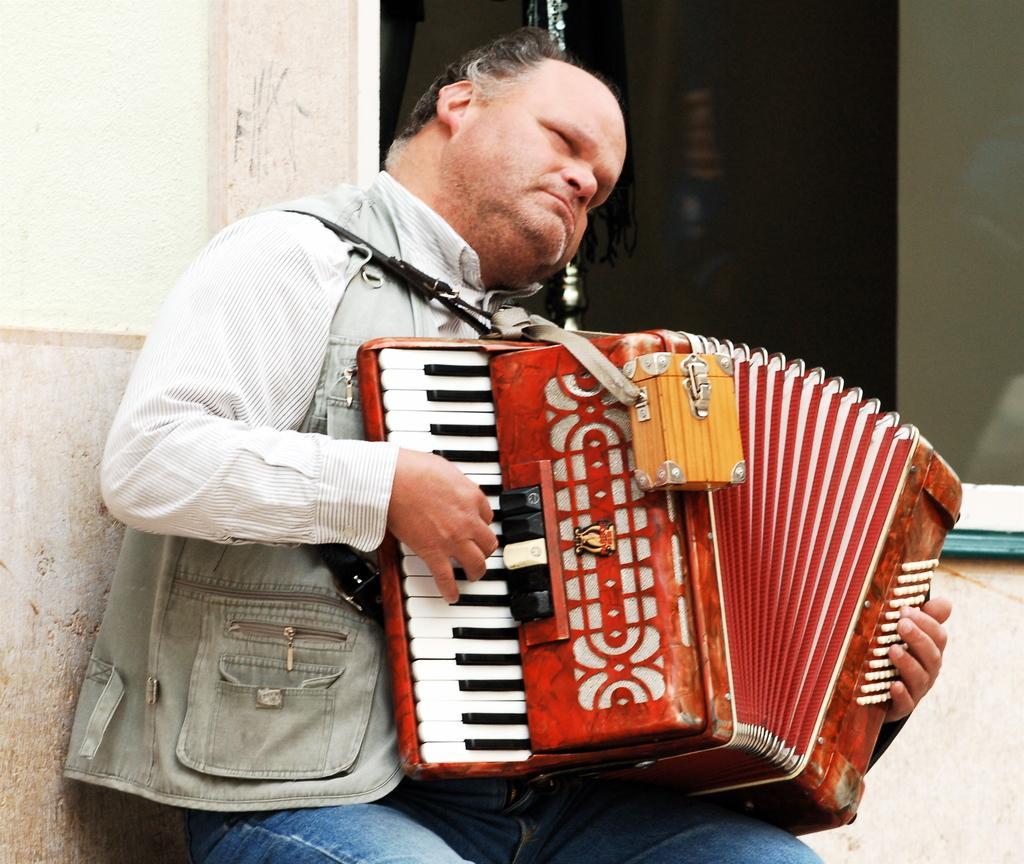In one or two sentences, can you explain what this image depicts? In this picture we can see a man is playing a musical instrument, on the left side there is a wall. 